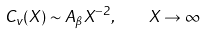<formula> <loc_0><loc_0><loc_500><loc_500>C _ { v } ( X ) \sim A _ { \beta } X ^ { - 2 } , \quad X \rightarrow \infty</formula> 